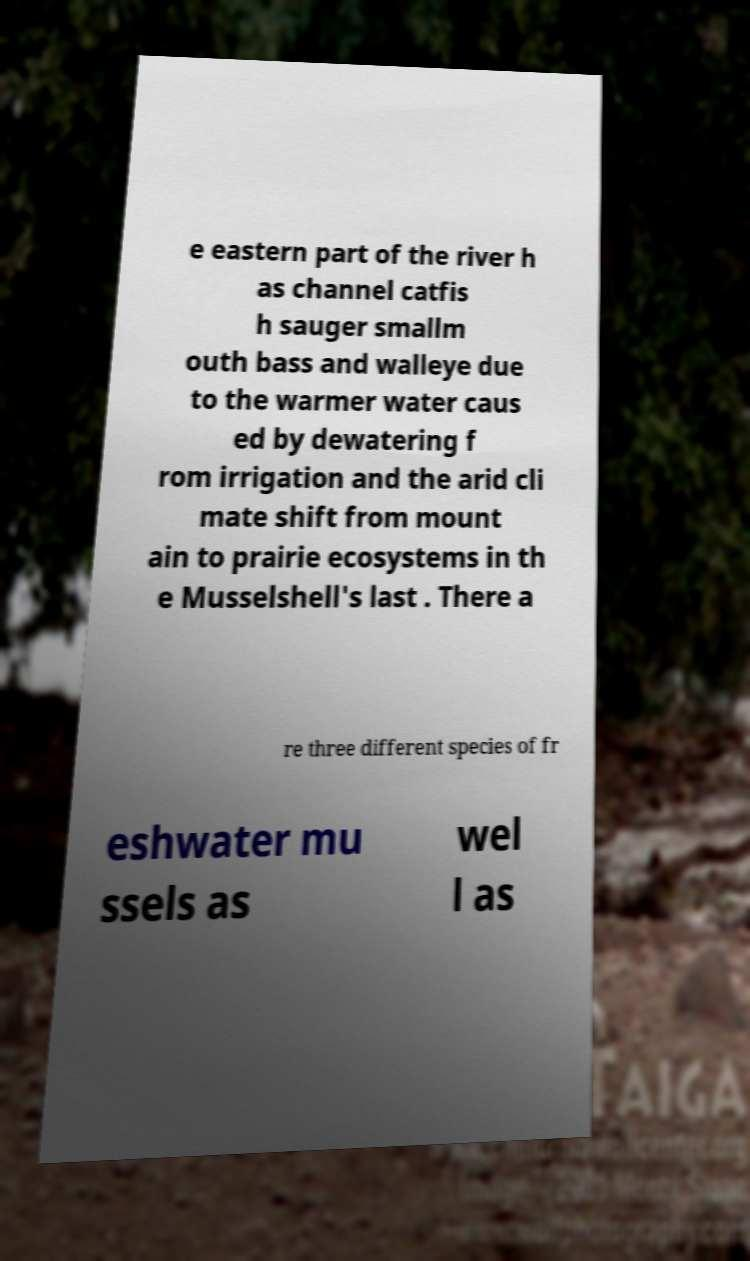Please identify and transcribe the text found in this image. e eastern part of the river h as channel catfis h sauger smallm outh bass and walleye due to the warmer water caus ed by dewatering f rom irrigation and the arid cli mate shift from mount ain to prairie ecosystems in th e Musselshell's last . There a re three different species of fr eshwater mu ssels as wel l as 